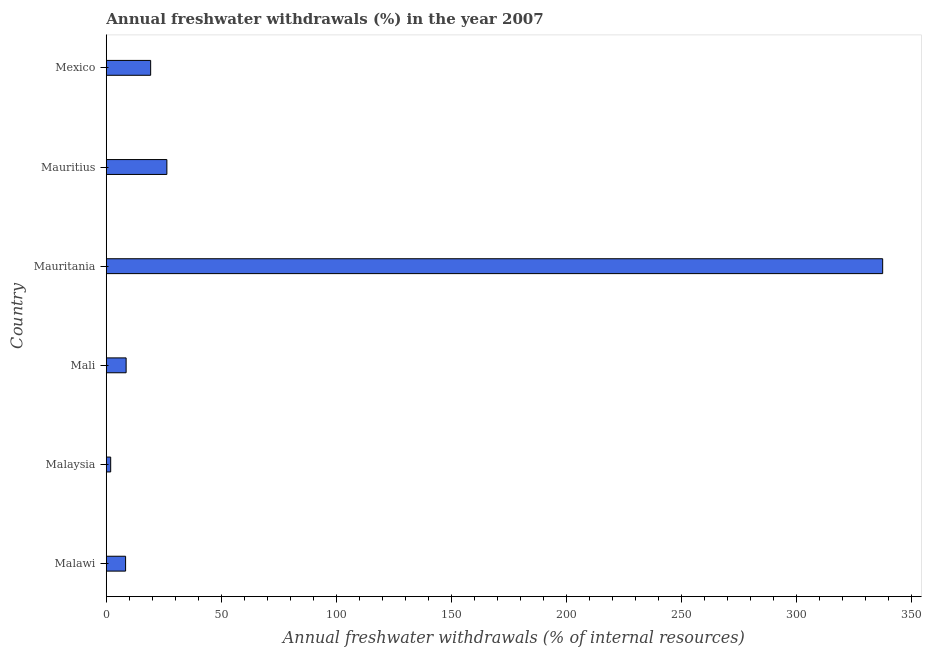Does the graph contain any zero values?
Your answer should be very brief. No. What is the title of the graph?
Offer a very short reply. Annual freshwater withdrawals (%) in the year 2007. What is the label or title of the X-axis?
Your answer should be compact. Annual freshwater withdrawals (% of internal resources). What is the annual freshwater withdrawals in Mali?
Give a very brief answer. 8.64. Across all countries, what is the maximum annual freshwater withdrawals?
Ensure brevity in your answer.  337.5. Across all countries, what is the minimum annual freshwater withdrawals?
Offer a very short reply. 1.93. In which country was the annual freshwater withdrawals maximum?
Ensure brevity in your answer.  Mauritania. In which country was the annual freshwater withdrawals minimum?
Your response must be concise. Malaysia. What is the sum of the annual freshwater withdrawals?
Your response must be concise. 402.14. What is the difference between the annual freshwater withdrawals in Malaysia and Mexico?
Your response must be concise. -17.37. What is the average annual freshwater withdrawals per country?
Your answer should be very brief. 67.02. What is the median annual freshwater withdrawals?
Give a very brief answer. 13.97. In how many countries, is the annual freshwater withdrawals greater than 50 %?
Give a very brief answer. 1. What is the ratio of the annual freshwater withdrawals in Mauritius to that in Mexico?
Provide a succinct answer. 1.36. What is the difference between the highest and the second highest annual freshwater withdrawals?
Offer a terse response. 311.15. Is the sum of the annual freshwater withdrawals in Malaysia and Mauritius greater than the maximum annual freshwater withdrawals across all countries?
Provide a short and direct response. No. What is the difference between the highest and the lowest annual freshwater withdrawals?
Offer a terse response. 335.57. How many countries are there in the graph?
Your answer should be compact. 6. Are the values on the major ticks of X-axis written in scientific E-notation?
Ensure brevity in your answer.  No. What is the Annual freshwater withdrawals (% of internal resources) in Malawi?
Give a very brief answer. 8.41. What is the Annual freshwater withdrawals (% of internal resources) in Malaysia?
Your answer should be compact. 1.93. What is the Annual freshwater withdrawals (% of internal resources) in Mali?
Keep it short and to the point. 8.64. What is the Annual freshwater withdrawals (% of internal resources) of Mauritania?
Offer a very short reply. 337.5. What is the Annual freshwater withdrawals (% of internal resources) of Mauritius?
Give a very brief answer. 26.35. What is the Annual freshwater withdrawals (% of internal resources) in Mexico?
Provide a succinct answer. 19.3. What is the difference between the Annual freshwater withdrawals (% of internal resources) in Malawi and Malaysia?
Provide a succinct answer. 6.48. What is the difference between the Annual freshwater withdrawals (% of internal resources) in Malawi and Mali?
Ensure brevity in your answer.  -0.24. What is the difference between the Annual freshwater withdrawals (% of internal resources) in Malawi and Mauritania?
Ensure brevity in your answer.  -329.09. What is the difference between the Annual freshwater withdrawals (% of internal resources) in Malawi and Mauritius?
Provide a short and direct response. -17.95. What is the difference between the Annual freshwater withdrawals (% of internal resources) in Malawi and Mexico?
Provide a succinct answer. -10.9. What is the difference between the Annual freshwater withdrawals (% of internal resources) in Malaysia and Mali?
Your answer should be compact. -6.71. What is the difference between the Annual freshwater withdrawals (% of internal resources) in Malaysia and Mauritania?
Provide a succinct answer. -335.57. What is the difference between the Annual freshwater withdrawals (% of internal resources) in Malaysia and Mauritius?
Make the answer very short. -24.42. What is the difference between the Annual freshwater withdrawals (% of internal resources) in Malaysia and Mexico?
Offer a terse response. -17.37. What is the difference between the Annual freshwater withdrawals (% of internal resources) in Mali and Mauritania?
Keep it short and to the point. -328.86. What is the difference between the Annual freshwater withdrawals (% of internal resources) in Mali and Mauritius?
Provide a succinct answer. -17.71. What is the difference between the Annual freshwater withdrawals (% of internal resources) in Mali and Mexico?
Your response must be concise. -10.66. What is the difference between the Annual freshwater withdrawals (% of internal resources) in Mauritania and Mauritius?
Provide a succinct answer. 311.15. What is the difference between the Annual freshwater withdrawals (% of internal resources) in Mauritania and Mexico?
Make the answer very short. 318.2. What is the difference between the Annual freshwater withdrawals (% of internal resources) in Mauritius and Mexico?
Keep it short and to the point. 7.05. What is the ratio of the Annual freshwater withdrawals (% of internal resources) in Malawi to that in Malaysia?
Your answer should be compact. 4.35. What is the ratio of the Annual freshwater withdrawals (% of internal resources) in Malawi to that in Mali?
Give a very brief answer. 0.97. What is the ratio of the Annual freshwater withdrawals (% of internal resources) in Malawi to that in Mauritania?
Your answer should be very brief. 0.03. What is the ratio of the Annual freshwater withdrawals (% of internal resources) in Malawi to that in Mauritius?
Make the answer very short. 0.32. What is the ratio of the Annual freshwater withdrawals (% of internal resources) in Malawi to that in Mexico?
Your response must be concise. 0.44. What is the ratio of the Annual freshwater withdrawals (% of internal resources) in Malaysia to that in Mali?
Offer a terse response. 0.22. What is the ratio of the Annual freshwater withdrawals (% of internal resources) in Malaysia to that in Mauritania?
Keep it short and to the point. 0.01. What is the ratio of the Annual freshwater withdrawals (% of internal resources) in Malaysia to that in Mauritius?
Ensure brevity in your answer.  0.07. What is the ratio of the Annual freshwater withdrawals (% of internal resources) in Malaysia to that in Mexico?
Keep it short and to the point. 0.1. What is the ratio of the Annual freshwater withdrawals (% of internal resources) in Mali to that in Mauritania?
Your answer should be very brief. 0.03. What is the ratio of the Annual freshwater withdrawals (% of internal resources) in Mali to that in Mauritius?
Offer a terse response. 0.33. What is the ratio of the Annual freshwater withdrawals (% of internal resources) in Mali to that in Mexico?
Keep it short and to the point. 0.45. What is the ratio of the Annual freshwater withdrawals (% of internal resources) in Mauritania to that in Mauritius?
Your response must be concise. 12.81. What is the ratio of the Annual freshwater withdrawals (% of internal resources) in Mauritania to that in Mexico?
Make the answer very short. 17.48. What is the ratio of the Annual freshwater withdrawals (% of internal resources) in Mauritius to that in Mexico?
Make the answer very short. 1.36. 